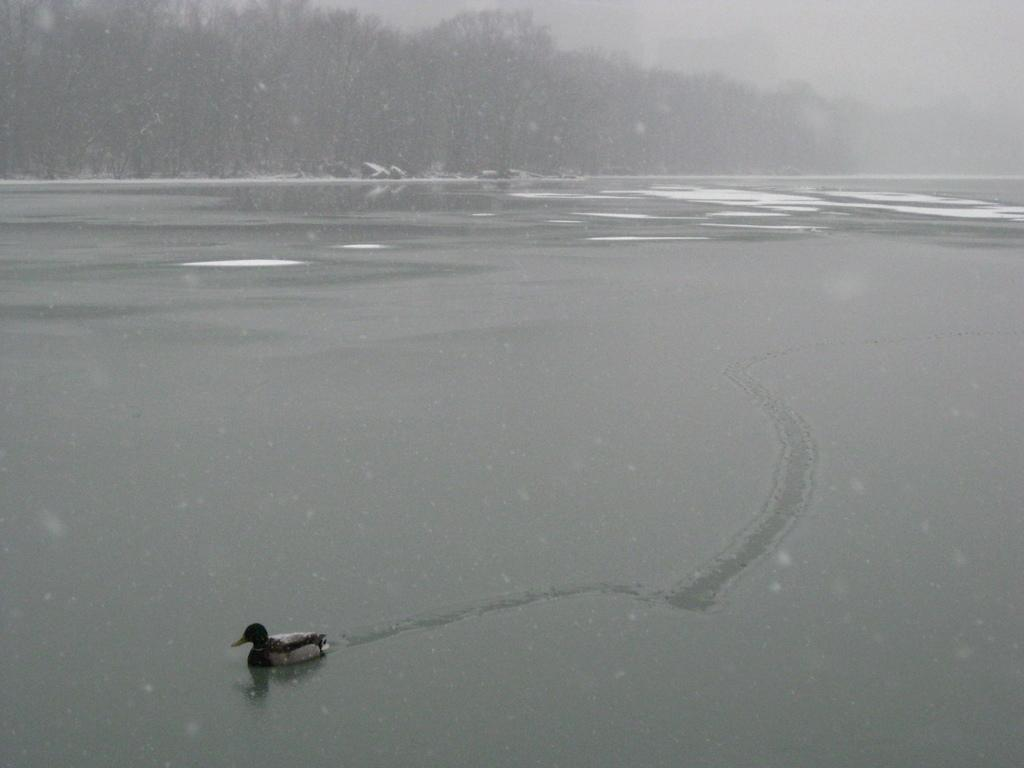What is the main subject of the image? The main subject of the image is a duck swimming on the water surface. What is the duck swimming on? The duck is swimming on a water surface. What can be seen in the background of the image? There are trees in the background of the image. What type of leather is the duck using to swim in the image? There is no leather present in the image, and the duck is swimming using its natural ability to swim in the water. 